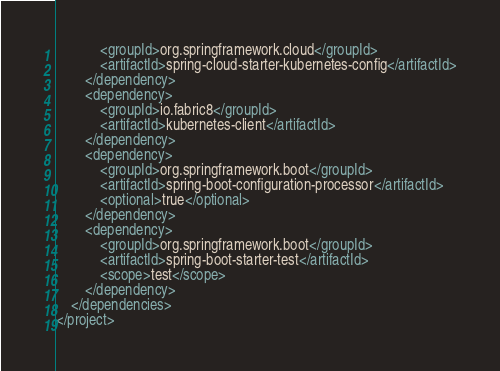Convert code to text. <code><loc_0><loc_0><loc_500><loc_500><_XML_>			<groupId>org.springframework.cloud</groupId>
			<artifactId>spring-cloud-starter-kubernetes-config</artifactId>
		</dependency>
		<dependency>
			<groupId>io.fabric8</groupId>
			<artifactId>kubernetes-client</artifactId>
		</dependency>
		<dependency>
			<groupId>org.springframework.boot</groupId>
			<artifactId>spring-boot-configuration-processor</artifactId>
			<optional>true</optional>
		</dependency>
		<dependency>
			<groupId>org.springframework.boot</groupId>
			<artifactId>spring-boot-starter-test</artifactId>
			<scope>test</scope>
		</dependency>
	</dependencies>
</project>
</code> 